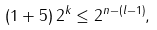Convert formula to latex. <formula><loc_0><loc_0><loc_500><loc_500>( 1 + 5 ) \, 2 ^ { k } \leq 2 ^ { n - ( l - 1 ) } ,</formula> 